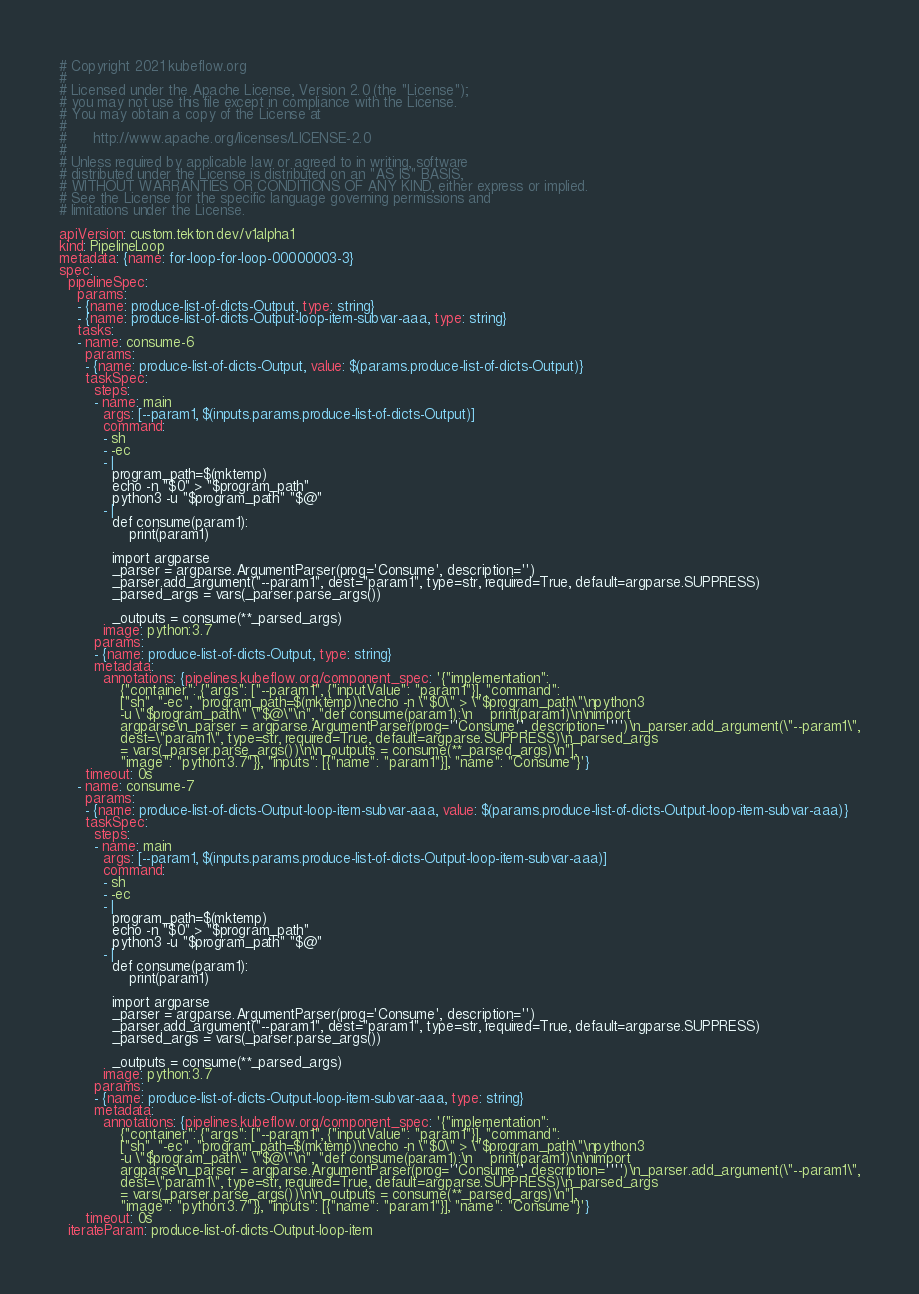<code> <loc_0><loc_0><loc_500><loc_500><_YAML_># Copyright 2021 kubeflow.org
#
# Licensed under the Apache License, Version 2.0 (the "License");
# you may not use this file except in compliance with the License.
# You may obtain a copy of the License at
#
#      http://www.apache.org/licenses/LICENSE-2.0
#
# Unless required by applicable law or agreed to in writing, software
# distributed under the License is distributed on an "AS IS" BASIS,
# WITHOUT WARRANTIES OR CONDITIONS OF ANY KIND, either express or implied.
# See the License for the specific language governing permissions and
# limitations under the License.

apiVersion: custom.tekton.dev/v1alpha1
kind: PipelineLoop
metadata: {name: for-loop-for-loop-00000003-3}
spec:
  pipelineSpec:
    params:
    - {name: produce-list-of-dicts-Output, type: string}
    - {name: produce-list-of-dicts-Output-loop-item-subvar-aaa, type: string}
    tasks:
    - name: consume-6
      params:
      - {name: produce-list-of-dicts-Output, value: $(params.produce-list-of-dicts-Output)}
      taskSpec:
        steps:
        - name: main
          args: [--param1, $(inputs.params.produce-list-of-dicts-Output)]
          command:
          - sh
          - -ec
          - |
            program_path=$(mktemp)
            echo -n "$0" > "$program_path"
            python3 -u "$program_path" "$@"
          - |
            def consume(param1):
                print(param1)

            import argparse
            _parser = argparse.ArgumentParser(prog='Consume', description='')
            _parser.add_argument("--param1", dest="param1", type=str, required=True, default=argparse.SUPPRESS)
            _parsed_args = vars(_parser.parse_args())

            _outputs = consume(**_parsed_args)
          image: python:3.7
        params:
        - {name: produce-list-of-dicts-Output, type: string}
        metadata:
          annotations: {pipelines.kubeflow.org/component_spec: '{"implementation":
              {"container": {"args": ["--param1", {"inputValue": "param1"}], "command":
              ["sh", "-ec", "program_path=$(mktemp)\necho -n \"$0\" > \"$program_path\"\npython3
              -u \"$program_path\" \"$@\"\n", "def consume(param1):\n    print(param1)\n\nimport
              argparse\n_parser = argparse.ArgumentParser(prog=''Consume'', description='''')\n_parser.add_argument(\"--param1\",
              dest=\"param1\", type=str, required=True, default=argparse.SUPPRESS)\n_parsed_args
              = vars(_parser.parse_args())\n\n_outputs = consume(**_parsed_args)\n"],
              "image": "python:3.7"}}, "inputs": [{"name": "param1"}], "name": "Consume"}'}
      timeout: 0s
    - name: consume-7
      params:
      - {name: produce-list-of-dicts-Output-loop-item-subvar-aaa, value: $(params.produce-list-of-dicts-Output-loop-item-subvar-aaa)}
      taskSpec:
        steps:
        - name: main
          args: [--param1, $(inputs.params.produce-list-of-dicts-Output-loop-item-subvar-aaa)]
          command:
          - sh
          - -ec
          - |
            program_path=$(mktemp)
            echo -n "$0" > "$program_path"
            python3 -u "$program_path" "$@"
          - |
            def consume(param1):
                print(param1)

            import argparse
            _parser = argparse.ArgumentParser(prog='Consume', description='')
            _parser.add_argument("--param1", dest="param1", type=str, required=True, default=argparse.SUPPRESS)
            _parsed_args = vars(_parser.parse_args())

            _outputs = consume(**_parsed_args)
          image: python:3.7
        params:
        - {name: produce-list-of-dicts-Output-loop-item-subvar-aaa, type: string}
        metadata:
          annotations: {pipelines.kubeflow.org/component_spec: '{"implementation":
              {"container": {"args": ["--param1", {"inputValue": "param1"}], "command":
              ["sh", "-ec", "program_path=$(mktemp)\necho -n \"$0\" > \"$program_path\"\npython3
              -u \"$program_path\" \"$@\"\n", "def consume(param1):\n    print(param1)\n\nimport
              argparse\n_parser = argparse.ArgumentParser(prog=''Consume'', description='''')\n_parser.add_argument(\"--param1\",
              dest=\"param1\", type=str, required=True, default=argparse.SUPPRESS)\n_parsed_args
              = vars(_parser.parse_args())\n\n_outputs = consume(**_parsed_args)\n"],
              "image": "python:3.7"}}, "inputs": [{"name": "param1"}], "name": "Consume"}'}
      timeout: 0s
  iterateParam: produce-list-of-dicts-Output-loop-item
</code> 